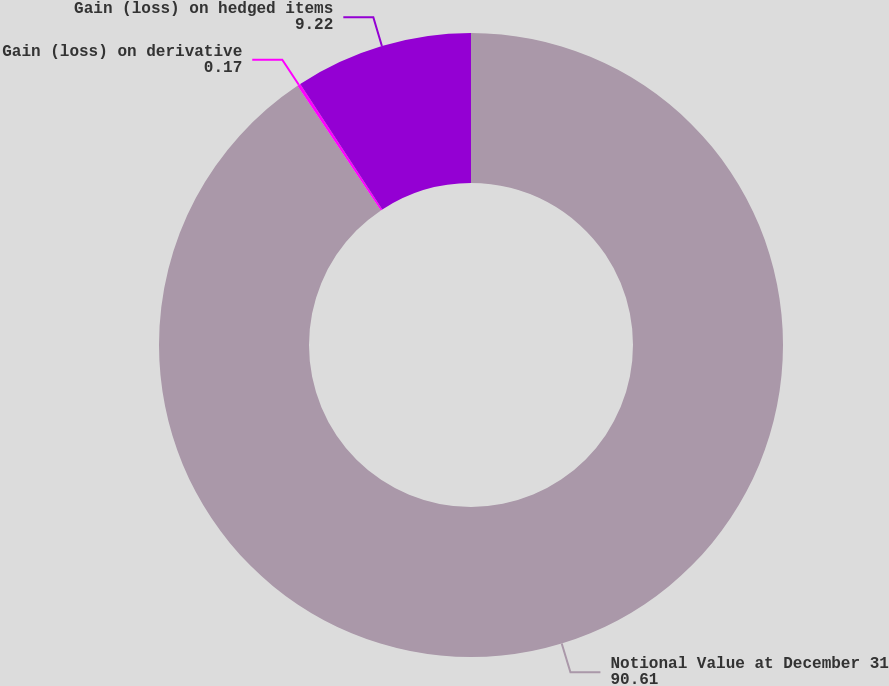<chart> <loc_0><loc_0><loc_500><loc_500><pie_chart><fcel>Notional Value at December 31<fcel>Gain (loss) on derivative<fcel>Gain (loss) on hedged items<nl><fcel>90.61%<fcel>0.17%<fcel>9.22%<nl></chart> 